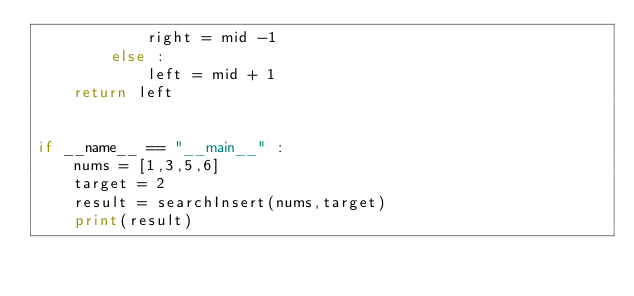Convert code to text. <code><loc_0><loc_0><loc_500><loc_500><_Python_>            right = mid -1
        else :
            left = mid + 1
    return left


if __name__ == "__main__" :
    nums = [1,3,5,6]
    target = 2
    result = searchInsert(nums,target)
    print(result)</code> 